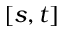<formula> <loc_0><loc_0><loc_500><loc_500>[ s , t ]</formula> 